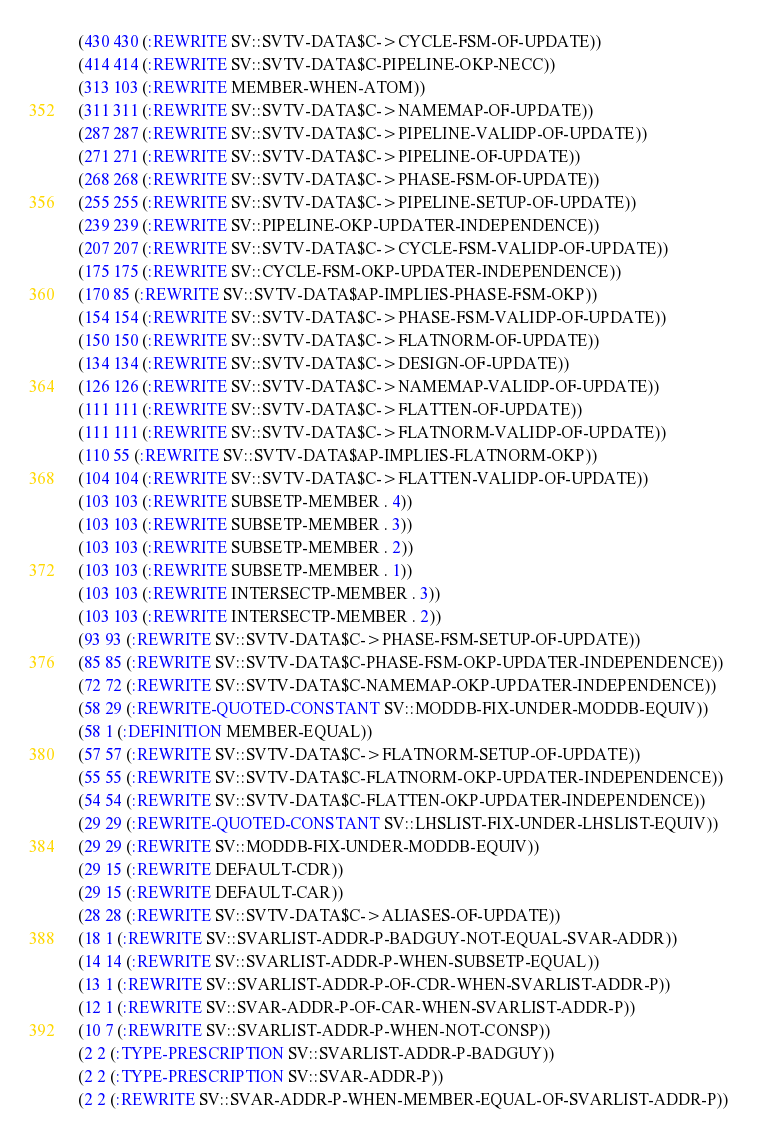<code> <loc_0><loc_0><loc_500><loc_500><_Lisp_> (430 430 (:REWRITE SV::SVTV-DATA$C->CYCLE-FSM-OF-UPDATE))
 (414 414 (:REWRITE SV::SVTV-DATA$C-PIPELINE-OKP-NECC))
 (313 103 (:REWRITE MEMBER-WHEN-ATOM))
 (311 311 (:REWRITE SV::SVTV-DATA$C->NAMEMAP-OF-UPDATE))
 (287 287 (:REWRITE SV::SVTV-DATA$C->PIPELINE-VALIDP-OF-UPDATE))
 (271 271 (:REWRITE SV::SVTV-DATA$C->PIPELINE-OF-UPDATE))
 (268 268 (:REWRITE SV::SVTV-DATA$C->PHASE-FSM-OF-UPDATE))
 (255 255 (:REWRITE SV::SVTV-DATA$C->PIPELINE-SETUP-OF-UPDATE))
 (239 239 (:REWRITE SV::PIPELINE-OKP-UPDATER-INDEPENDENCE))
 (207 207 (:REWRITE SV::SVTV-DATA$C->CYCLE-FSM-VALIDP-OF-UPDATE))
 (175 175 (:REWRITE SV::CYCLE-FSM-OKP-UPDATER-INDEPENDENCE))
 (170 85 (:REWRITE SV::SVTV-DATA$AP-IMPLIES-PHASE-FSM-OKP))
 (154 154 (:REWRITE SV::SVTV-DATA$C->PHASE-FSM-VALIDP-OF-UPDATE))
 (150 150 (:REWRITE SV::SVTV-DATA$C->FLATNORM-OF-UPDATE))
 (134 134 (:REWRITE SV::SVTV-DATA$C->DESIGN-OF-UPDATE))
 (126 126 (:REWRITE SV::SVTV-DATA$C->NAMEMAP-VALIDP-OF-UPDATE))
 (111 111 (:REWRITE SV::SVTV-DATA$C->FLATTEN-OF-UPDATE))
 (111 111 (:REWRITE SV::SVTV-DATA$C->FLATNORM-VALIDP-OF-UPDATE))
 (110 55 (:REWRITE SV::SVTV-DATA$AP-IMPLIES-FLATNORM-OKP))
 (104 104 (:REWRITE SV::SVTV-DATA$C->FLATTEN-VALIDP-OF-UPDATE))
 (103 103 (:REWRITE SUBSETP-MEMBER . 4))
 (103 103 (:REWRITE SUBSETP-MEMBER . 3))
 (103 103 (:REWRITE SUBSETP-MEMBER . 2))
 (103 103 (:REWRITE SUBSETP-MEMBER . 1))
 (103 103 (:REWRITE INTERSECTP-MEMBER . 3))
 (103 103 (:REWRITE INTERSECTP-MEMBER . 2))
 (93 93 (:REWRITE SV::SVTV-DATA$C->PHASE-FSM-SETUP-OF-UPDATE))
 (85 85 (:REWRITE SV::SVTV-DATA$C-PHASE-FSM-OKP-UPDATER-INDEPENDENCE))
 (72 72 (:REWRITE SV::SVTV-DATA$C-NAMEMAP-OKP-UPDATER-INDEPENDENCE))
 (58 29 (:REWRITE-QUOTED-CONSTANT SV::MODDB-FIX-UNDER-MODDB-EQUIV))
 (58 1 (:DEFINITION MEMBER-EQUAL))
 (57 57 (:REWRITE SV::SVTV-DATA$C->FLATNORM-SETUP-OF-UPDATE))
 (55 55 (:REWRITE SV::SVTV-DATA$C-FLATNORM-OKP-UPDATER-INDEPENDENCE))
 (54 54 (:REWRITE SV::SVTV-DATA$C-FLATTEN-OKP-UPDATER-INDEPENDENCE))
 (29 29 (:REWRITE-QUOTED-CONSTANT SV::LHSLIST-FIX-UNDER-LHSLIST-EQUIV))
 (29 29 (:REWRITE SV::MODDB-FIX-UNDER-MODDB-EQUIV))
 (29 15 (:REWRITE DEFAULT-CDR))
 (29 15 (:REWRITE DEFAULT-CAR))
 (28 28 (:REWRITE SV::SVTV-DATA$C->ALIASES-OF-UPDATE))
 (18 1 (:REWRITE SV::SVARLIST-ADDR-P-BADGUY-NOT-EQUAL-SVAR-ADDR))
 (14 14 (:REWRITE SV::SVARLIST-ADDR-P-WHEN-SUBSETP-EQUAL))
 (13 1 (:REWRITE SV::SVARLIST-ADDR-P-OF-CDR-WHEN-SVARLIST-ADDR-P))
 (12 1 (:REWRITE SV::SVAR-ADDR-P-OF-CAR-WHEN-SVARLIST-ADDR-P))
 (10 7 (:REWRITE SV::SVARLIST-ADDR-P-WHEN-NOT-CONSP))
 (2 2 (:TYPE-PRESCRIPTION SV::SVARLIST-ADDR-P-BADGUY))
 (2 2 (:TYPE-PRESCRIPTION SV::SVAR-ADDR-P))
 (2 2 (:REWRITE SV::SVAR-ADDR-P-WHEN-MEMBER-EQUAL-OF-SVARLIST-ADDR-P))</code> 